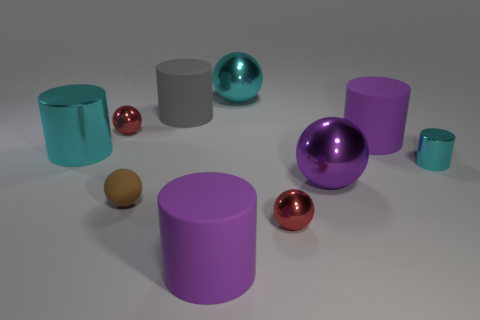What is the size of the ball that is the same color as the tiny metallic cylinder?
Give a very brief answer. Large. How many objects are either metal balls in front of the brown rubber ball or tiny metal things?
Ensure brevity in your answer.  3. Are there the same number of purple rubber cylinders that are left of the large gray matte cylinder and big spheres?
Keep it short and to the point. No. Is the size of the purple metallic object the same as the brown sphere?
Your answer should be very brief. No. There is a shiny cylinder that is the same size as the gray rubber object; what color is it?
Provide a succinct answer. Cyan. There is a brown matte thing; is it the same size as the purple object that is in front of the tiny brown object?
Your answer should be very brief. No. How many other cylinders have the same color as the tiny cylinder?
Offer a very short reply. 1. What number of objects are gray metallic cylinders or small spheres that are left of the brown object?
Provide a short and direct response. 1. Is the size of the red metallic object that is in front of the large cyan cylinder the same as the cyan shiny object to the left of the brown matte thing?
Offer a very short reply. No. Are there any other brown objects that have the same material as the brown object?
Ensure brevity in your answer.  No. 